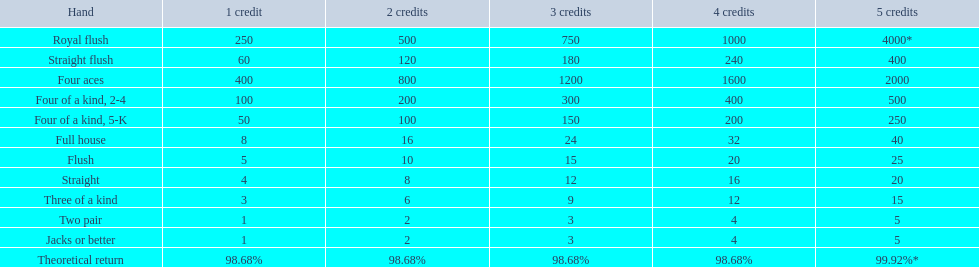Can you define the hands? Royal flush, Straight flush, Four aces, Four of a kind, 2-4, Four of a kind, 5-K, Full house, Flush, Straight, Three of a kind, Two pair, Jacks or better. Which of them is placed at a higher level? Royal flush. 